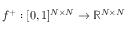Convert formula to latex. <formula><loc_0><loc_0><loc_500><loc_500>f ^ { + } \colon [ 0 , 1 ] ^ { N \times N } \rightarrow \mathbb { R } ^ { N \times N }</formula> 